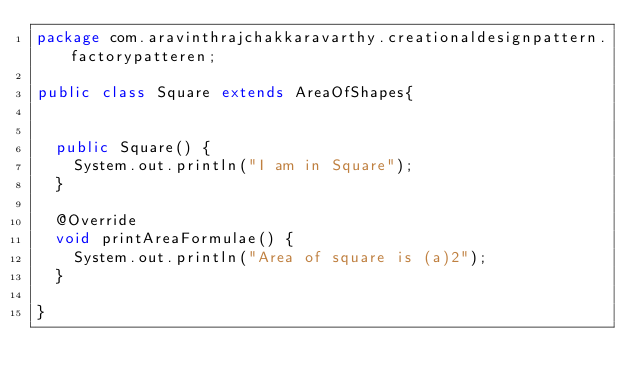<code> <loc_0><loc_0><loc_500><loc_500><_Java_>package com.aravinthrajchakkaravarthy.creationaldesignpattern.factorypatteren;

public class Square extends AreaOfShapes{

	
	public Square() {
		System.out.println("I am in Square");
	}

	@Override
	void printAreaFormulae() {
		System.out.println("Area of square is (a)2");
	}

}
</code> 